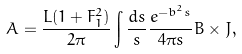<formula> <loc_0><loc_0><loc_500><loc_500>A = \frac { L ( 1 + F _ { 1 } ^ { 2 } ) } { 2 \pi } \int \frac { d s } { s } \frac { e ^ { - b ^ { 2 } s } } { 4 \pi s } B \times J ,</formula> 